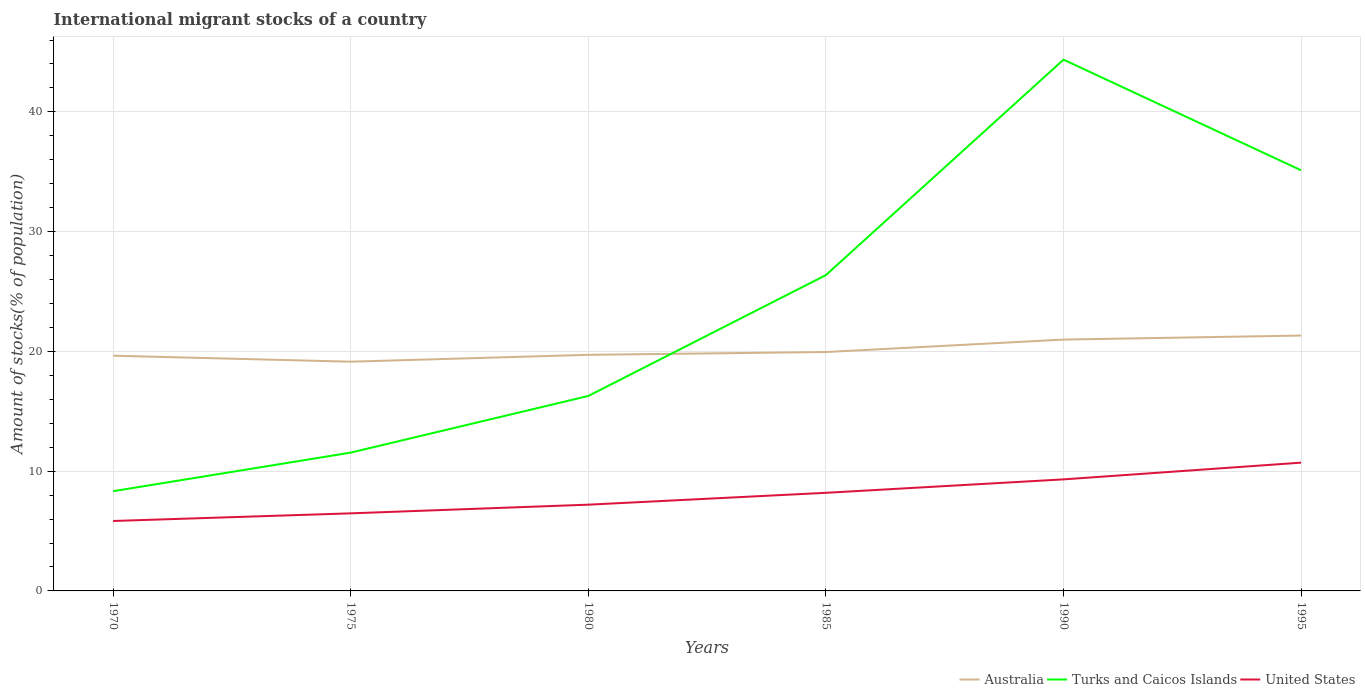Across all years, what is the maximum amount of stocks in in Australia?
Ensure brevity in your answer.  19.14. What is the total amount of stocks in in Turks and Caicos Islands in the graph?
Provide a short and direct response. -18.05. What is the difference between the highest and the second highest amount of stocks in in United States?
Your answer should be very brief. 4.87. What is the difference between the highest and the lowest amount of stocks in in United States?
Provide a succinct answer. 3. How many lines are there?
Your answer should be compact. 3. How many years are there in the graph?
Ensure brevity in your answer.  6. What is the difference between two consecutive major ticks on the Y-axis?
Make the answer very short. 10. Are the values on the major ticks of Y-axis written in scientific E-notation?
Make the answer very short. No. Where does the legend appear in the graph?
Keep it short and to the point. Bottom right. How are the legend labels stacked?
Give a very brief answer. Horizontal. What is the title of the graph?
Make the answer very short. International migrant stocks of a country. Does "Dominican Republic" appear as one of the legend labels in the graph?
Keep it short and to the point. No. What is the label or title of the Y-axis?
Your answer should be very brief. Amount of stocks(% of population). What is the Amount of stocks(% of population) in Australia in 1970?
Offer a terse response. 19.64. What is the Amount of stocks(% of population) of Turks and Caicos Islands in 1970?
Ensure brevity in your answer.  8.33. What is the Amount of stocks(% of population) of United States in 1970?
Provide a succinct answer. 5.84. What is the Amount of stocks(% of population) in Australia in 1975?
Keep it short and to the point. 19.14. What is the Amount of stocks(% of population) of Turks and Caicos Islands in 1975?
Your response must be concise. 11.55. What is the Amount of stocks(% of population) in United States in 1975?
Your answer should be compact. 6.48. What is the Amount of stocks(% of population) of Australia in 1980?
Keep it short and to the point. 19.71. What is the Amount of stocks(% of population) of Turks and Caicos Islands in 1980?
Provide a succinct answer. 16.28. What is the Amount of stocks(% of population) of United States in 1980?
Offer a very short reply. 7.2. What is the Amount of stocks(% of population) in Australia in 1985?
Your answer should be very brief. 19.95. What is the Amount of stocks(% of population) in Turks and Caicos Islands in 1985?
Your answer should be compact. 26.37. What is the Amount of stocks(% of population) of United States in 1985?
Ensure brevity in your answer.  8.19. What is the Amount of stocks(% of population) in Australia in 1990?
Provide a succinct answer. 20.99. What is the Amount of stocks(% of population) in Turks and Caicos Islands in 1990?
Offer a very short reply. 44.36. What is the Amount of stocks(% of population) in United States in 1990?
Offer a very short reply. 9.31. What is the Amount of stocks(% of population) of Australia in 1995?
Offer a very short reply. 21.32. What is the Amount of stocks(% of population) of Turks and Caicos Islands in 1995?
Your response must be concise. 35.12. What is the Amount of stocks(% of population) of United States in 1995?
Provide a short and direct response. 10.71. Across all years, what is the maximum Amount of stocks(% of population) in Australia?
Your answer should be compact. 21.32. Across all years, what is the maximum Amount of stocks(% of population) of Turks and Caicos Islands?
Make the answer very short. 44.36. Across all years, what is the maximum Amount of stocks(% of population) in United States?
Offer a very short reply. 10.71. Across all years, what is the minimum Amount of stocks(% of population) of Australia?
Your response must be concise. 19.14. Across all years, what is the minimum Amount of stocks(% of population) in Turks and Caicos Islands?
Offer a very short reply. 8.33. Across all years, what is the minimum Amount of stocks(% of population) of United States?
Keep it short and to the point. 5.84. What is the total Amount of stocks(% of population) of Australia in the graph?
Give a very brief answer. 120.76. What is the total Amount of stocks(% of population) in Turks and Caicos Islands in the graph?
Your answer should be compact. 142.02. What is the total Amount of stocks(% of population) in United States in the graph?
Make the answer very short. 47.74. What is the difference between the Amount of stocks(% of population) in Australia in 1970 and that in 1975?
Your answer should be compact. 0.5. What is the difference between the Amount of stocks(% of population) in Turks and Caicos Islands in 1970 and that in 1975?
Make the answer very short. -3.22. What is the difference between the Amount of stocks(% of population) in United States in 1970 and that in 1975?
Keep it short and to the point. -0.64. What is the difference between the Amount of stocks(% of population) in Australia in 1970 and that in 1980?
Offer a very short reply. -0.07. What is the difference between the Amount of stocks(% of population) in Turks and Caicos Islands in 1970 and that in 1980?
Your answer should be very brief. -7.95. What is the difference between the Amount of stocks(% of population) in United States in 1970 and that in 1980?
Ensure brevity in your answer.  -1.36. What is the difference between the Amount of stocks(% of population) in Australia in 1970 and that in 1985?
Provide a short and direct response. -0.31. What is the difference between the Amount of stocks(% of population) in Turks and Caicos Islands in 1970 and that in 1985?
Make the answer very short. -18.05. What is the difference between the Amount of stocks(% of population) of United States in 1970 and that in 1985?
Your answer should be very brief. -2.35. What is the difference between the Amount of stocks(% of population) of Australia in 1970 and that in 1990?
Your answer should be compact. -1.35. What is the difference between the Amount of stocks(% of population) of Turks and Caicos Islands in 1970 and that in 1990?
Your answer should be compact. -36.04. What is the difference between the Amount of stocks(% of population) of United States in 1970 and that in 1990?
Make the answer very short. -3.48. What is the difference between the Amount of stocks(% of population) of Australia in 1970 and that in 1995?
Provide a short and direct response. -1.68. What is the difference between the Amount of stocks(% of population) of Turks and Caicos Islands in 1970 and that in 1995?
Provide a short and direct response. -26.8. What is the difference between the Amount of stocks(% of population) of United States in 1970 and that in 1995?
Offer a very short reply. -4.87. What is the difference between the Amount of stocks(% of population) of Australia in 1975 and that in 1980?
Give a very brief answer. -0.57. What is the difference between the Amount of stocks(% of population) in Turks and Caicos Islands in 1975 and that in 1980?
Provide a short and direct response. -4.73. What is the difference between the Amount of stocks(% of population) of United States in 1975 and that in 1980?
Provide a succinct answer. -0.72. What is the difference between the Amount of stocks(% of population) of Australia in 1975 and that in 1985?
Keep it short and to the point. -0.81. What is the difference between the Amount of stocks(% of population) in Turks and Caicos Islands in 1975 and that in 1985?
Your response must be concise. -14.82. What is the difference between the Amount of stocks(% of population) of United States in 1975 and that in 1985?
Provide a succinct answer. -1.71. What is the difference between the Amount of stocks(% of population) of Australia in 1975 and that in 1990?
Your response must be concise. -1.84. What is the difference between the Amount of stocks(% of population) in Turks and Caicos Islands in 1975 and that in 1990?
Give a very brief answer. -32.81. What is the difference between the Amount of stocks(% of population) of United States in 1975 and that in 1990?
Make the answer very short. -2.84. What is the difference between the Amount of stocks(% of population) in Australia in 1975 and that in 1995?
Offer a terse response. -2.18. What is the difference between the Amount of stocks(% of population) of Turks and Caicos Islands in 1975 and that in 1995?
Ensure brevity in your answer.  -23.58. What is the difference between the Amount of stocks(% of population) of United States in 1975 and that in 1995?
Your answer should be compact. -4.23. What is the difference between the Amount of stocks(% of population) of Australia in 1980 and that in 1985?
Make the answer very short. -0.23. What is the difference between the Amount of stocks(% of population) in Turks and Caicos Islands in 1980 and that in 1985?
Your answer should be compact. -10.09. What is the difference between the Amount of stocks(% of population) of United States in 1980 and that in 1985?
Provide a succinct answer. -0.99. What is the difference between the Amount of stocks(% of population) in Australia in 1980 and that in 1990?
Ensure brevity in your answer.  -1.27. What is the difference between the Amount of stocks(% of population) of Turks and Caicos Islands in 1980 and that in 1990?
Offer a very short reply. -28.08. What is the difference between the Amount of stocks(% of population) in United States in 1980 and that in 1990?
Provide a short and direct response. -2.11. What is the difference between the Amount of stocks(% of population) of Australia in 1980 and that in 1995?
Offer a very short reply. -1.61. What is the difference between the Amount of stocks(% of population) in Turks and Caicos Islands in 1980 and that in 1995?
Give a very brief answer. -18.85. What is the difference between the Amount of stocks(% of population) in United States in 1980 and that in 1995?
Keep it short and to the point. -3.51. What is the difference between the Amount of stocks(% of population) in Australia in 1985 and that in 1990?
Offer a very short reply. -1.04. What is the difference between the Amount of stocks(% of population) in Turks and Caicos Islands in 1985 and that in 1990?
Ensure brevity in your answer.  -17.99. What is the difference between the Amount of stocks(% of population) of United States in 1985 and that in 1990?
Your answer should be very brief. -1.12. What is the difference between the Amount of stocks(% of population) in Australia in 1985 and that in 1995?
Offer a terse response. -1.38. What is the difference between the Amount of stocks(% of population) of Turks and Caicos Islands in 1985 and that in 1995?
Your answer should be very brief. -8.75. What is the difference between the Amount of stocks(% of population) of United States in 1985 and that in 1995?
Offer a terse response. -2.52. What is the difference between the Amount of stocks(% of population) of Australia in 1990 and that in 1995?
Your response must be concise. -0.34. What is the difference between the Amount of stocks(% of population) of Turks and Caicos Islands in 1990 and that in 1995?
Your answer should be compact. 9.24. What is the difference between the Amount of stocks(% of population) in United States in 1990 and that in 1995?
Make the answer very short. -1.4. What is the difference between the Amount of stocks(% of population) in Australia in 1970 and the Amount of stocks(% of population) in Turks and Caicos Islands in 1975?
Offer a terse response. 8.09. What is the difference between the Amount of stocks(% of population) in Australia in 1970 and the Amount of stocks(% of population) in United States in 1975?
Offer a terse response. 13.16. What is the difference between the Amount of stocks(% of population) in Turks and Caicos Islands in 1970 and the Amount of stocks(% of population) in United States in 1975?
Offer a terse response. 1.85. What is the difference between the Amount of stocks(% of population) of Australia in 1970 and the Amount of stocks(% of population) of Turks and Caicos Islands in 1980?
Offer a very short reply. 3.36. What is the difference between the Amount of stocks(% of population) of Australia in 1970 and the Amount of stocks(% of population) of United States in 1980?
Offer a terse response. 12.44. What is the difference between the Amount of stocks(% of population) of Turks and Caicos Islands in 1970 and the Amount of stocks(% of population) of United States in 1980?
Provide a short and direct response. 1.13. What is the difference between the Amount of stocks(% of population) of Australia in 1970 and the Amount of stocks(% of population) of Turks and Caicos Islands in 1985?
Your answer should be compact. -6.73. What is the difference between the Amount of stocks(% of population) in Australia in 1970 and the Amount of stocks(% of population) in United States in 1985?
Offer a very short reply. 11.45. What is the difference between the Amount of stocks(% of population) of Turks and Caicos Islands in 1970 and the Amount of stocks(% of population) of United States in 1985?
Your response must be concise. 0.14. What is the difference between the Amount of stocks(% of population) in Australia in 1970 and the Amount of stocks(% of population) in Turks and Caicos Islands in 1990?
Offer a very short reply. -24.72. What is the difference between the Amount of stocks(% of population) in Australia in 1970 and the Amount of stocks(% of population) in United States in 1990?
Keep it short and to the point. 10.33. What is the difference between the Amount of stocks(% of population) of Turks and Caicos Islands in 1970 and the Amount of stocks(% of population) of United States in 1990?
Provide a succinct answer. -0.99. What is the difference between the Amount of stocks(% of population) in Australia in 1970 and the Amount of stocks(% of population) in Turks and Caicos Islands in 1995?
Make the answer very short. -15.48. What is the difference between the Amount of stocks(% of population) of Australia in 1970 and the Amount of stocks(% of population) of United States in 1995?
Offer a terse response. 8.93. What is the difference between the Amount of stocks(% of population) of Turks and Caicos Islands in 1970 and the Amount of stocks(% of population) of United States in 1995?
Offer a very short reply. -2.38. What is the difference between the Amount of stocks(% of population) of Australia in 1975 and the Amount of stocks(% of population) of Turks and Caicos Islands in 1980?
Your answer should be very brief. 2.86. What is the difference between the Amount of stocks(% of population) of Australia in 1975 and the Amount of stocks(% of population) of United States in 1980?
Your response must be concise. 11.94. What is the difference between the Amount of stocks(% of population) in Turks and Caicos Islands in 1975 and the Amount of stocks(% of population) in United States in 1980?
Ensure brevity in your answer.  4.35. What is the difference between the Amount of stocks(% of population) of Australia in 1975 and the Amount of stocks(% of population) of Turks and Caicos Islands in 1985?
Provide a succinct answer. -7.23. What is the difference between the Amount of stocks(% of population) of Australia in 1975 and the Amount of stocks(% of population) of United States in 1985?
Make the answer very short. 10.95. What is the difference between the Amount of stocks(% of population) in Turks and Caicos Islands in 1975 and the Amount of stocks(% of population) in United States in 1985?
Ensure brevity in your answer.  3.36. What is the difference between the Amount of stocks(% of population) of Australia in 1975 and the Amount of stocks(% of population) of Turks and Caicos Islands in 1990?
Keep it short and to the point. -25.22. What is the difference between the Amount of stocks(% of population) in Australia in 1975 and the Amount of stocks(% of population) in United States in 1990?
Offer a very short reply. 9.83. What is the difference between the Amount of stocks(% of population) of Turks and Caicos Islands in 1975 and the Amount of stocks(% of population) of United States in 1990?
Provide a succinct answer. 2.23. What is the difference between the Amount of stocks(% of population) of Australia in 1975 and the Amount of stocks(% of population) of Turks and Caicos Islands in 1995?
Provide a short and direct response. -15.98. What is the difference between the Amount of stocks(% of population) in Australia in 1975 and the Amount of stocks(% of population) in United States in 1995?
Ensure brevity in your answer.  8.43. What is the difference between the Amount of stocks(% of population) in Turks and Caicos Islands in 1975 and the Amount of stocks(% of population) in United States in 1995?
Provide a succinct answer. 0.84. What is the difference between the Amount of stocks(% of population) in Australia in 1980 and the Amount of stocks(% of population) in Turks and Caicos Islands in 1985?
Provide a succinct answer. -6.66. What is the difference between the Amount of stocks(% of population) in Australia in 1980 and the Amount of stocks(% of population) in United States in 1985?
Your answer should be compact. 11.52. What is the difference between the Amount of stocks(% of population) of Turks and Caicos Islands in 1980 and the Amount of stocks(% of population) of United States in 1985?
Provide a succinct answer. 8.09. What is the difference between the Amount of stocks(% of population) of Australia in 1980 and the Amount of stocks(% of population) of Turks and Caicos Islands in 1990?
Make the answer very short. -24.65. What is the difference between the Amount of stocks(% of population) in Turks and Caicos Islands in 1980 and the Amount of stocks(% of population) in United States in 1990?
Your answer should be very brief. 6.96. What is the difference between the Amount of stocks(% of population) of Australia in 1980 and the Amount of stocks(% of population) of Turks and Caicos Islands in 1995?
Provide a short and direct response. -15.41. What is the difference between the Amount of stocks(% of population) of Australia in 1980 and the Amount of stocks(% of population) of United States in 1995?
Provide a short and direct response. 9. What is the difference between the Amount of stocks(% of population) of Turks and Caicos Islands in 1980 and the Amount of stocks(% of population) of United States in 1995?
Provide a succinct answer. 5.57. What is the difference between the Amount of stocks(% of population) in Australia in 1985 and the Amount of stocks(% of population) in Turks and Caicos Islands in 1990?
Your answer should be compact. -24.42. What is the difference between the Amount of stocks(% of population) in Australia in 1985 and the Amount of stocks(% of population) in United States in 1990?
Keep it short and to the point. 10.63. What is the difference between the Amount of stocks(% of population) of Turks and Caicos Islands in 1985 and the Amount of stocks(% of population) of United States in 1990?
Make the answer very short. 17.06. What is the difference between the Amount of stocks(% of population) of Australia in 1985 and the Amount of stocks(% of population) of Turks and Caicos Islands in 1995?
Offer a very short reply. -15.18. What is the difference between the Amount of stocks(% of population) of Australia in 1985 and the Amount of stocks(% of population) of United States in 1995?
Give a very brief answer. 9.24. What is the difference between the Amount of stocks(% of population) in Turks and Caicos Islands in 1985 and the Amount of stocks(% of population) in United States in 1995?
Keep it short and to the point. 15.66. What is the difference between the Amount of stocks(% of population) of Australia in 1990 and the Amount of stocks(% of population) of Turks and Caicos Islands in 1995?
Keep it short and to the point. -14.14. What is the difference between the Amount of stocks(% of population) of Australia in 1990 and the Amount of stocks(% of population) of United States in 1995?
Provide a short and direct response. 10.28. What is the difference between the Amount of stocks(% of population) in Turks and Caicos Islands in 1990 and the Amount of stocks(% of population) in United States in 1995?
Make the answer very short. 33.65. What is the average Amount of stocks(% of population) of Australia per year?
Your response must be concise. 20.13. What is the average Amount of stocks(% of population) in Turks and Caicos Islands per year?
Provide a succinct answer. 23.67. What is the average Amount of stocks(% of population) of United States per year?
Give a very brief answer. 7.96. In the year 1970, what is the difference between the Amount of stocks(% of population) of Australia and Amount of stocks(% of population) of Turks and Caicos Islands?
Your response must be concise. 11.31. In the year 1970, what is the difference between the Amount of stocks(% of population) in Australia and Amount of stocks(% of population) in United States?
Offer a terse response. 13.8. In the year 1970, what is the difference between the Amount of stocks(% of population) in Turks and Caicos Islands and Amount of stocks(% of population) in United States?
Ensure brevity in your answer.  2.49. In the year 1975, what is the difference between the Amount of stocks(% of population) of Australia and Amount of stocks(% of population) of Turks and Caicos Islands?
Offer a terse response. 7.59. In the year 1975, what is the difference between the Amount of stocks(% of population) of Australia and Amount of stocks(% of population) of United States?
Keep it short and to the point. 12.66. In the year 1975, what is the difference between the Amount of stocks(% of population) in Turks and Caicos Islands and Amount of stocks(% of population) in United States?
Provide a succinct answer. 5.07. In the year 1980, what is the difference between the Amount of stocks(% of population) of Australia and Amount of stocks(% of population) of Turks and Caicos Islands?
Provide a short and direct response. 3.44. In the year 1980, what is the difference between the Amount of stocks(% of population) in Australia and Amount of stocks(% of population) in United States?
Your response must be concise. 12.51. In the year 1980, what is the difference between the Amount of stocks(% of population) of Turks and Caicos Islands and Amount of stocks(% of population) of United States?
Your response must be concise. 9.08. In the year 1985, what is the difference between the Amount of stocks(% of population) in Australia and Amount of stocks(% of population) in Turks and Caicos Islands?
Your answer should be very brief. -6.42. In the year 1985, what is the difference between the Amount of stocks(% of population) of Australia and Amount of stocks(% of population) of United States?
Your response must be concise. 11.76. In the year 1985, what is the difference between the Amount of stocks(% of population) of Turks and Caicos Islands and Amount of stocks(% of population) of United States?
Keep it short and to the point. 18.18. In the year 1990, what is the difference between the Amount of stocks(% of population) of Australia and Amount of stocks(% of population) of Turks and Caicos Islands?
Your answer should be compact. -23.38. In the year 1990, what is the difference between the Amount of stocks(% of population) of Australia and Amount of stocks(% of population) of United States?
Your response must be concise. 11.67. In the year 1990, what is the difference between the Amount of stocks(% of population) of Turks and Caicos Islands and Amount of stocks(% of population) of United States?
Your answer should be very brief. 35.05. In the year 1995, what is the difference between the Amount of stocks(% of population) of Australia and Amount of stocks(% of population) of Turks and Caicos Islands?
Make the answer very short. -13.8. In the year 1995, what is the difference between the Amount of stocks(% of population) of Australia and Amount of stocks(% of population) of United States?
Your response must be concise. 10.61. In the year 1995, what is the difference between the Amount of stocks(% of population) in Turks and Caicos Islands and Amount of stocks(% of population) in United States?
Your answer should be very brief. 24.41. What is the ratio of the Amount of stocks(% of population) of Australia in 1970 to that in 1975?
Provide a succinct answer. 1.03. What is the ratio of the Amount of stocks(% of population) of Turks and Caicos Islands in 1970 to that in 1975?
Make the answer very short. 0.72. What is the ratio of the Amount of stocks(% of population) of United States in 1970 to that in 1975?
Ensure brevity in your answer.  0.9. What is the ratio of the Amount of stocks(% of population) in Turks and Caicos Islands in 1970 to that in 1980?
Your response must be concise. 0.51. What is the ratio of the Amount of stocks(% of population) in United States in 1970 to that in 1980?
Offer a very short reply. 0.81. What is the ratio of the Amount of stocks(% of population) in Australia in 1970 to that in 1985?
Provide a short and direct response. 0.98. What is the ratio of the Amount of stocks(% of population) in Turks and Caicos Islands in 1970 to that in 1985?
Your response must be concise. 0.32. What is the ratio of the Amount of stocks(% of population) in United States in 1970 to that in 1985?
Offer a very short reply. 0.71. What is the ratio of the Amount of stocks(% of population) of Australia in 1970 to that in 1990?
Ensure brevity in your answer.  0.94. What is the ratio of the Amount of stocks(% of population) of Turks and Caicos Islands in 1970 to that in 1990?
Your answer should be very brief. 0.19. What is the ratio of the Amount of stocks(% of population) in United States in 1970 to that in 1990?
Offer a terse response. 0.63. What is the ratio of the Amount of stocks(% of population) in Australia in 1970 to that in 1995?
Your answer should be very brief. 0.92. What is the ratio of the Amount of stocks(% of population) of Turks and Caicos Islands in 1970 to that in 1995?
Offer a terse response. 0.24. What is the ratio of the Amount of stocks(% of population) in United States in 1970 to that in 1995?
Keep it short and to the point. 0.55. What is the ratio of the Amount of stocks(% of population) in Australia in 1975 to that in 1980?
Your response must be concise. 0.97. What is the ratio of the Amount of stocks(% of population) of Turks and Caicos Islands in 1975 to that in 1980?
Your answer should be compact. 0.71. What is the ratio of the Amount of stocks(% of population) in United States in 1975 to that in 1980?
Your answer should be very brief. 0.9. What is the ratio of the Amount of stocks(% of population) of Australia in 1975 to that in 1985?
Provide a succinct answer. 0.96. What is the ratio of the Amount of stocks(% of population) of Turks and Caicos Islands in 1975 to that in 1985?
Provide a short and direct response. 0.44. What is the ratio of the Amount of stocks(% of population) of United States in 1975 to that in 1985?
Provide a succinct answer. 0.79. What is the ratio of the Amount of stocks(% of population) in Australia in 1975 to that in 1990?
Provide a succinct answer. 0.91. What is the ratio of the Amount of stocks(% of population) in Turks and Caicos Islands in 1975 to that in 1990?
Your response must be concise. 0.26. What is the ratio of the Amount of stocks(% of population) in United States in 1975 to that in 1990?
Give a very brief answer. 0.7. What is the ratio of the Amount of stocks(% of population) of Australia in 1975 to that in 1995?
Your answer should be compact. 0.9. What is the ratio of the Amount of stocks(% of population) in Turks and Caicos Islands in 1975 to that in 1995?
Offer a very short reply. 0.33. What is the ratio of the Amount of stocks(% of population) of United States in 1975 to that in 1995?
Your answer should be very brief. 0.6. What is the ratio of the Amount of stocks(% of population) of Australia in 1980 to that in 1985?
Keep it short and to the point. 0.99. What is the ratio of the Amount of stocks(% of population) of Turks and Caicos Islands in 1980 to that in 1985?
Ensure brevity in your answer.  0.62. What is the ratio of the Amount of stocks(% of population) in United States in 1980 to that in 1985?
Provide a short and direct response. 0.88. What is the ratio of the Amount of stocks(% of population) in Australia in 1980 to that in 1990?
Give a very brief answer. 0.94. What is the ratio of the Amount of stocks(% of population) of Turks and Caicos Islands in 1980 to that in 1990?
Provide a succinct answer. 0.37. What is the ratio of the Amount of stocks(% of population) in United States in 1980 to that in 1990?
Your response must be concise. 0.77. What is the ratio of the Amount of stocks(% of population) in Australia in 1980 to that in 1995?
Keep it short and to the point. 0.92. What is the ratio of the Amount of stocks(% of population) of Turks and Caicos Islands in 1980 to that in 1995?
Ensure brevity in your answer.  0.46. What is the ratio of the Amount of stocks(% of population) of United States in 1980 to that in 1995?
Your answer should be very brief. 0.67. What is the ratio of the Amount of stocks(% of population) of Australia in 1985 to that in 1990?
Provide a succinct answer. 0.95. What is the ratio of the Amount of stocks(% of population) of Turks and Caicos Islands in 1985 to that in 1990?
Ensure brevity in your answer.  0.59. What is the ratio of the Amount of stocks(% of population) in United States in 1985 to that in 1990?
Keep it short and to the point. 0.88. What is the ratio of the Amount of stocks(% of population) in Australia in 1985 to that in 1995?
Your answer should be compact. 0.94. What is the ratio of the Amount of stocks(% of population) of Turks and Caicos Islands in 1985 to that in 1995?
Offer a very short reply. 0.75. What is the ratio of the Amount of stocks(% of population) of United States in 1985 to that in 1995?
Your response must be concise. 0.76. What is the ratio of the Amount of stocks(% of population) in Australia in 1990 to that in 1995?
Offer a terse response. 0.98. What is the ratio of the Amount of stocks(% of population) in Turks and Caicos Islands in 1990 to that in 1995?
Your response must be concise. 1.26. What is the ratio of the Amount of stocks(% of population) of United States in 1990 to that in 1995?
Keep it short and to the point. 0.87. What is the difference between the highest and the second highest Amount of stocks(% of population) in Australia?
Offer a very short reply. 0.34. What is the difference between the highest and the second highest Amount of stocks(% of population) in Turks and Caicos Islands?
Offer a very short reply. 9.24. What is the difference between the highest and the second highest Amount of stocks(% of population) in United States?
Ensure brevity in your answer.  1.4. What is the difference between the highest and the lowest Amount of stocks(% of population) of Australia?
Your answer should be very brief. 2.18. What is the difference between the highest and the lowest Amount of stocks(% of population) of Turks and Caicos Islands?
Provide a short and direct response. 36.04. What is the difference between the highest and the lowest Amount of stocks(% of population) in United States?
Your answer should be very brief. 4.87. 